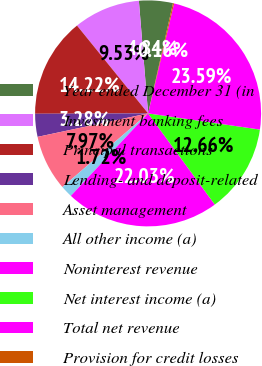Convert chart. <chart><loc_0><loc_0><loc_500><loc_500><pie_chart><fcel>Year ended December 31 (in<fcel>Investment banking fees<fcel>Principal transactions<fcel>Lending- and deposit-related<fcel>Asset management<fcel>All other income (a)<fcel>Noninterest revenue<fcel>Net interest income (a)<fcel>Total net revenue<fcel>Provision for credit losses<nl><fcel>4.84%<fcel>9.53%<fcel>14.22%<fcel>3.28%<fcel>7.97%<fcel>1.72%<fcel>22.03%<fcel>12.66%<fcel>23.59%<fcel>0.16%<nl></chart> 